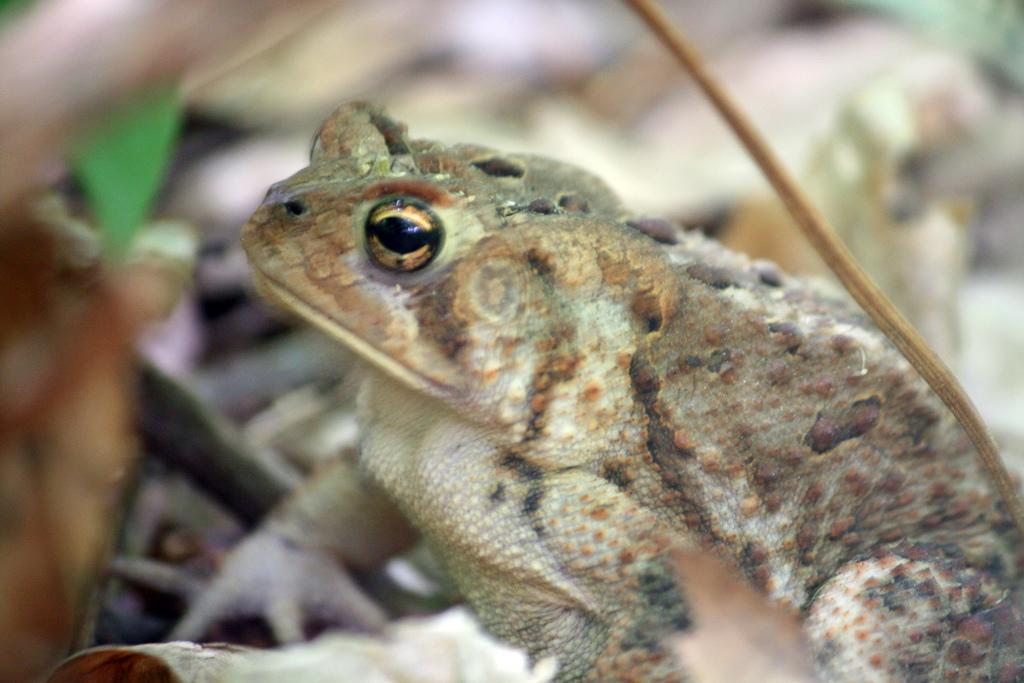What animal is present in the image? There is a frog in the image. In which direction is the frog facing? The frog is facing towards the left side. Can you describe the background of the image? The background of the image is blurred. What type of van can be seen in the image? There is no van present in the image; it only features a frog. 